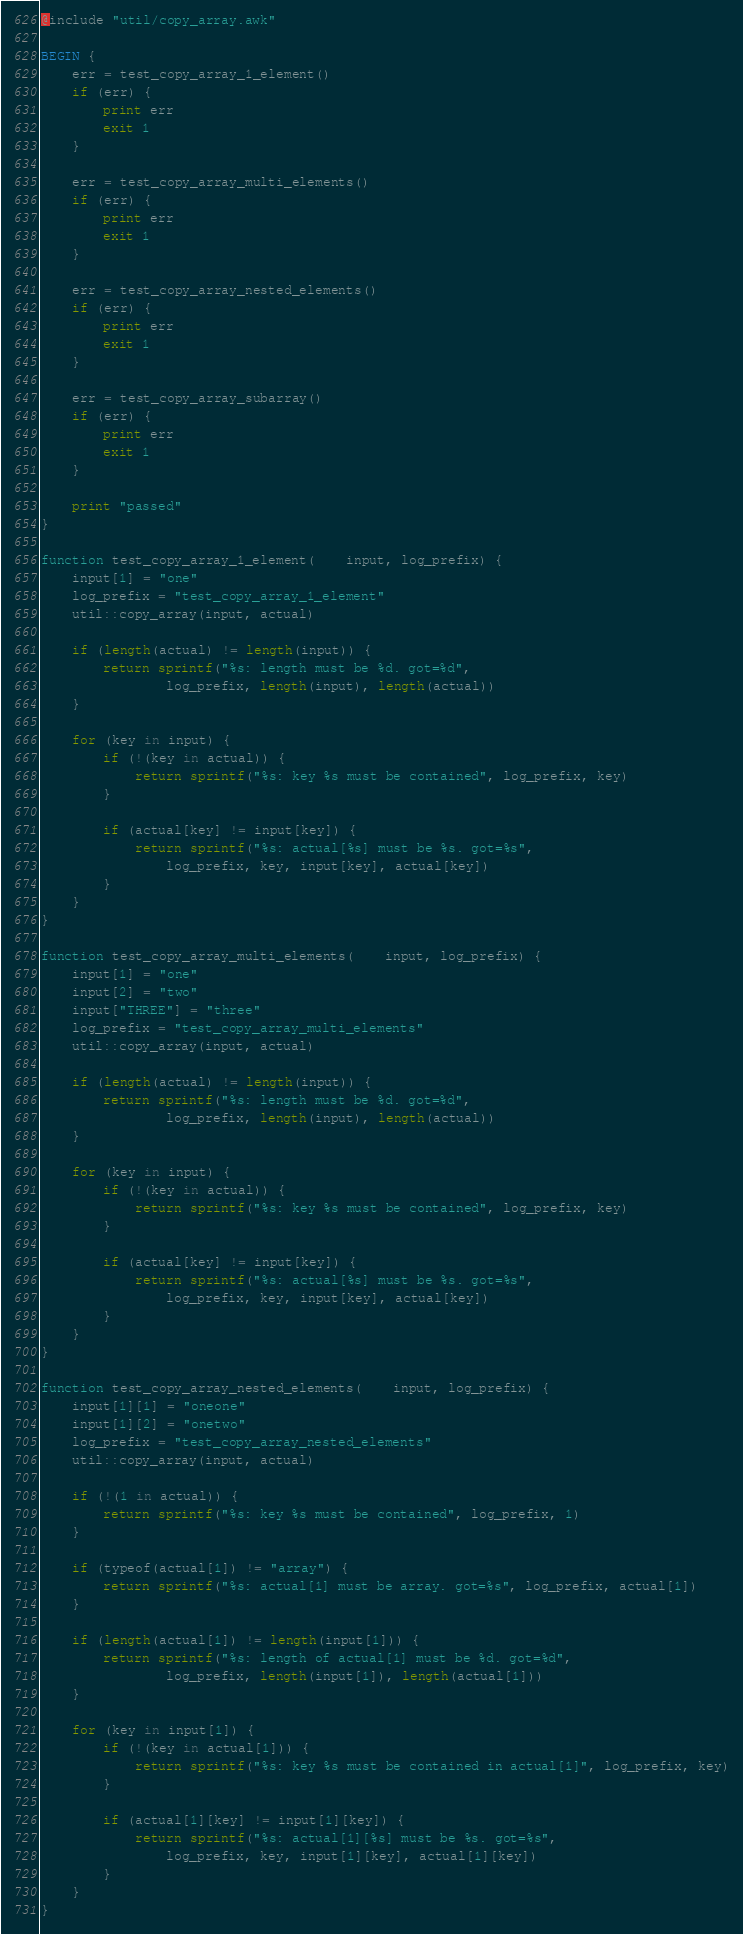<code> <loc_0><loc_0><loc_500><loc_500><_Awk_>@include "util/copy_array.awk"

BEGIN {
    err = test_copy_array_1_element()
    if (err) {
        print err
        exit 1
    }

    err = test_copy_array_multi_elements()
    if (err) {
        print err
        exit 1
    }

    err = test_copy_array_nested_elements()
    if (err) {
        print err
        exit 1
    }

    err = test_copy_array_subarray()
    if (err) {
        print err
        exit 1
    }

    print "passed"
}

function test_copy_array_1_element(    input, log_prefix) {
    input[1] = "one"
    log_prefix = "test_copy_array_1_element"
    util::copy_array(input, actual)

    if (length(actual) != length(input)) {
        return sprintf("%s: length must be %d. got=%d",
                log_prefix, length(input), length(actual))
    }

    for (key in input) {
        if (!(key in actual)) {
            return sprintf("%s: key %s must be contained", log_prefix, key)
        }
    
        if (actual[key] != input[key]) {
            return sprintf("%s: actual[%s] must be %s. got=%s",
                log_prefix, key, input[key], actual[key])
        }
    }
}

function test_copy_array_multi_elements(    input, log_prefix) {
    input[1] = "one"
    input[2] = "two"
    input["THREE"] = "three"
    log_prefix = "test_copy_array_multi_elements"
    util::copy_array(input, actual)

    if (length(actual) != length(input)) {
        return sprintf("%s: length must be %d. got=%d", 
                log_prefix, length(input), length(actual))
    }

    for (key in input) {
        if (!(key in actual)) {
            return sprintf("%s: key %s must be contained", log_prefix, key)
        }

        if (actual[key] != input[key]) {
            return sprintf("%s: actual[%s] must be %s. got=%s",
                log_prefix, key, input[key], actual[key])
        }
    }
}

function test_copy_array_nested_elements(    input, log_prefix) {
    input[1][1] = "oneone"
    input[1][2] = "onetwo"
    log_prefix = "test_copy_array_nested_elements"
    util::copy_array(input, actual)

    if (!(1 in actual)) {
        return sprintf("%s: key %s must be contained", log_prefix, 1)
    }

    if (typeof(actual[1]) != "array") {
        return sprintf("%s: actual[1] must be array. got=%s", log_prefix, actual[1])
    }

    if (length(actual[1]) != length(input[1])) {
        return sprintf("%s: length of actual[1] must be %d. got=%d",
                log_prefix, length(input[1]), length(actual[1]))
    }

    for (key in input[1]) {
        if (!(key in actual[1])) {
            return sprintf("%s: key %s must be contained in actual[1]", log_prefix, key)
        }
    
        if (actual[1][key] != input[1][key]) {
            return sprintf("%s: actual[1][%s] must be %s. got=%s",
                log_prefix, key, input[1][key], actual[1][key])
        }
    }
}
</code> 